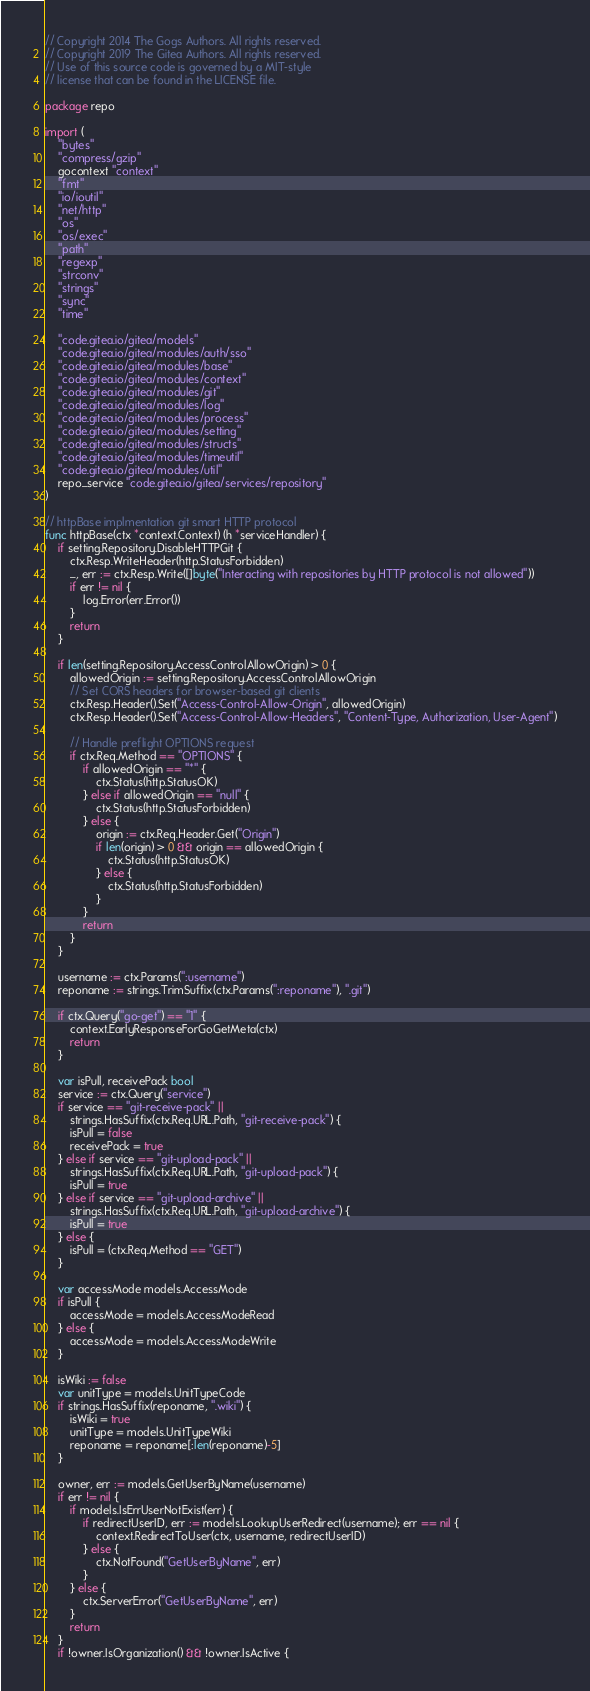Convert code to text. <code><loc_0><loc_0><loc_500><loc_500><_Go_>// Copyright 2014 The Gogs Authors. All rights reserved.
// Copyright 2019 The Gitea Authors. All rights reserved.
// Use of this source code is governed by a MIT-style
// license that can be found in the LICENSE file.

package repo

import (
	"bytes"
	"compress/gzip"
	gocontext "context"
	"fmt"
	"io/ioutil"
	"net/http"
	"os"
	"os/exec"
	"path"
	"regexp"
	"strconv"
	"strings"
	"sync"
	"time"

	"code.gitea.io/gitea/models"
	"code.gitea.io/gitea/modules/auth/sso"
	"code.gitea.io/gitea/modules/base"
	"code.gitea.io/gitea/modules/context"
	"code.gitea.io/gitea/modules/git"
	"code.gitea.io/gitea/modules/log"
	"code.gitea.io/gitea/modules/process"
	"code.gitea.io/gitea/modules/setting"
	"code.gitea.io/gitea/modules/structs"
	"code.gitea.io/gitea/modules/timeutil"
	"code.gitea.io/gitea/modules/util"
	repo_service "code.gitea.io/gitea/services/repository"
)

// httpBase implmentation git smart HTTP protocol
func httpBase(ctx *context.Context) (h *serviceHandler) {
	if setting.Repository.DisableHTTPGit {
		ctx.Resp.WriteHeader(http.StatusForbidden)
		_, err := ctx.Resp.Write([]byte("Interacting with repositories by HTTP protocol is not allowed"))
		if err != nil {
			log.Error(err.Error())
		}
		return
	}

	if len(setting.Repository.AccessControlAllowOrigin) > 0 {
		allowedOrigin := setting.Repository.AccessControlAllowOrigin
		// Set CORS headers for browser-based git clients
		ctx.Resp.Header().Set("Access-Control-Allow-Origin", allowedOrigin)
		ctx.Resp.Header().Set("Access-Control-Allow-Headers", "Content-Type, Authorization, User-Agent")

		// Handle preflight OPTIONS request
		if ctx.Req.Method == "OPTIONS" {
			if allowedOrigin == "*" {
				ctx.Status(http.StatusOK)
			} else if allowedOrigin == "null" {
				ctx.Status(http.StatusForbidden)
			} else {
				origin := ctx.Req.Header.Get("Origin")
				if len(origin) > 0 && origin == allowedOrigin {
					ctx.Status(http.StatusOK)
				} else {
					ctx.Status(http.StatusForbidden)
				}
			}
			return
		}
	}

	username := ctx.Params(":username")
	reponame := strings.TrimSuffix(ctx.Params(":reponame"), ".git")

	if ctx.Query("go-get") == "1" {
		context.EarlyResponseForGoGetMeta(ctx)
		return
	}

	var isPull, receivePack bool
	service := ctx.Query("service")
	if service == "git-receive-pack" ||
		strings.HasSuffix(ctx.Req.URL.Path, "git-receive-pack") {
		isPull = false
		receivePack = true
	} else if service == "git-upload-pack" ||
		strings.HasSuffix(ctx.Req.URL.Path, "git-upload-pack") {
		isPull = true
	} else if service == "git-upload-archive" ||
		strings.HasSuffix(ctx.Req.URL.Path, "git-upload-archive") {
		isPull = true
	} else {
		isPull = (ctx.Req.Method == "GET")
	}

	var accessMode models.AccessMode
	if isPull {
		accessMode = models.AccessModeRead
	} else {
		accessMode = models.AccessModeWrite
	}

	isWiki := false
	var unitType = models.UnitTypeCode
	if strings.HasSuffix(reponame, ".wiki") {
		isWiki = true
		unitType = models.UnitTypeWiki
		reponame = reponame[:len(reponame)-5]
	}

	owner, err := models.GetUserByName(username)
	if err != nil {
		if models.IsErrUserNotExist(err) {
			if redirectUserID, err := models.LookupUserRedirect(username); err == nil {
				context.RedirectToUser(ctx, username, redirectUserID)
			} else {
				ctx.NotFound("GetUserByName", err)
			}
		} else {
			ctx.ServerError("GetUserByName", err)
		}
		return
	}
	if !owner.IsOrganization() && !owner.IsActive {</code> 